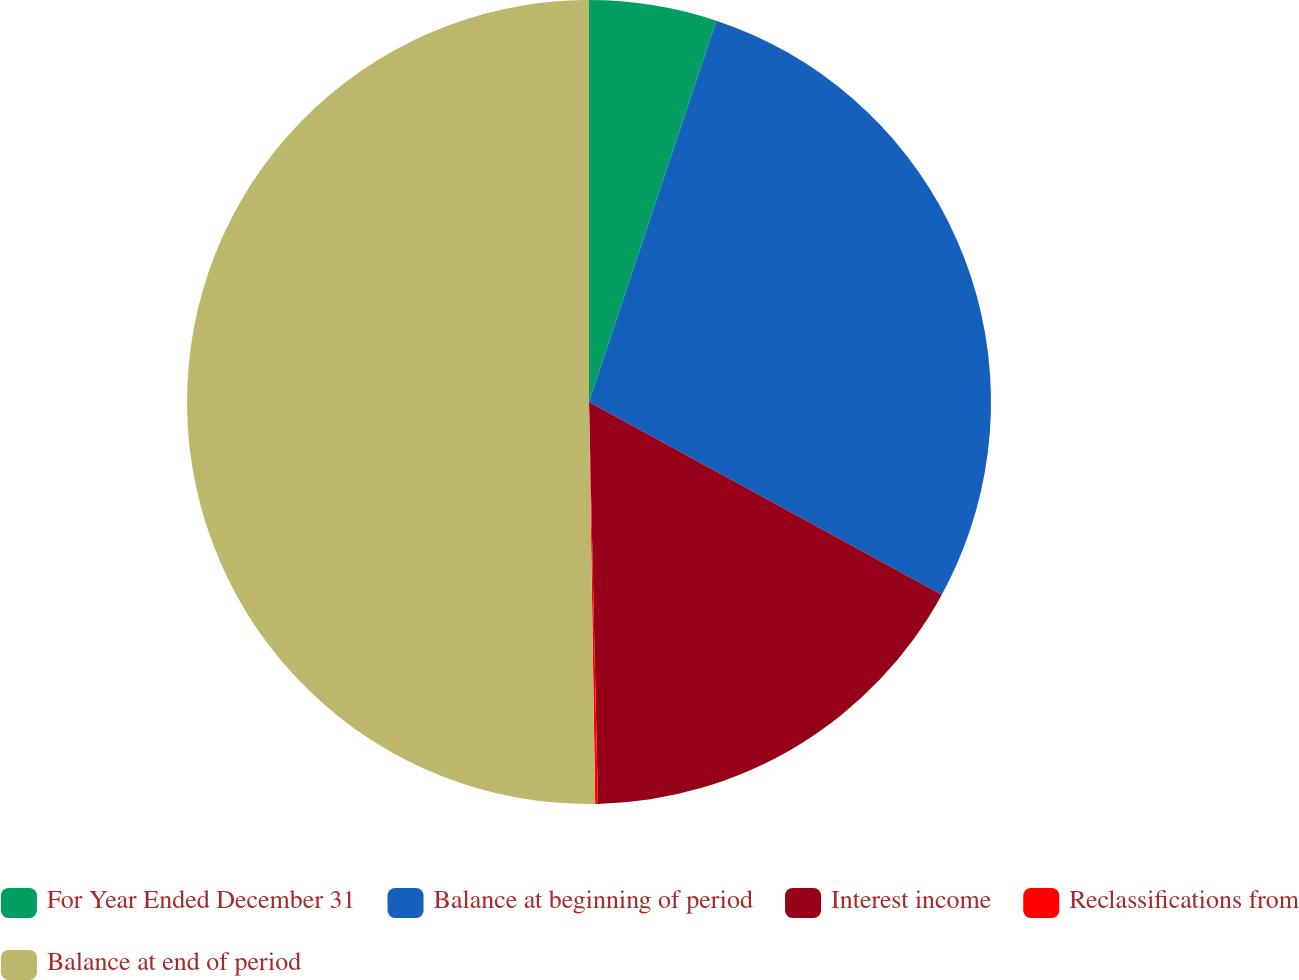<chart> <loc_0><loc_0><loc_500><loc_500><pie_chart><fcel>For Year Ended December 31<fcel>Balance at beginning of period<fcel>Interest income<fcel>Reclassifications from<fcel>Balance at end of period<nl><fcel>5.13%<fcel>27.83%<fcel>16.69%<fcel>0.11%<fcel>50.25%<nl></chart> 